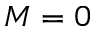<formula> <loc_0><loc_0><loc_500><loc_500>M = 0</formula> 